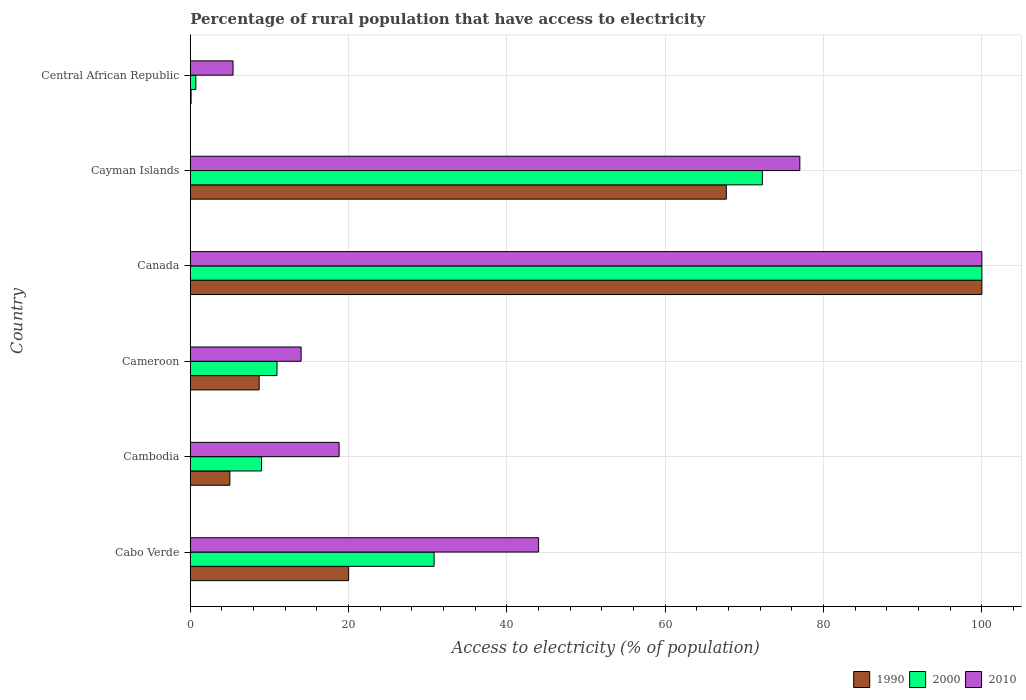How many groups of bars are there?
Your response must be concise. 6. Are the number of bars per tick equal to the number of legend labels?
Ensure brevity in your answer.  Yes. Are the number of bars on each tick of the Y-axis equal?
Provide a short and direct response. Yes. How many bars are there on the 2nd tick from the bottom?
Your answer should be compact. 3. What is the label of the 5th group of bars from the top?
Your answer should be compact. Cambodia. What is the percentage of rural population that have access to electricity in 2010 in Canada?
Your response must be concise. 100. In which country was the percentage of rural population that have access to electricity in 2000 minimum?
Provide a succinct answer. Central African Republic. What is the total percentage of rural population that have access to electricity in 2010 in the graph?
Provide a short and direct response. 259.2. What is the difference between the percentage of rural population that have access to electricity in 2000 in Cameroon and that in Cayman Islands?
Provide a succinct answer. -61.31. What is the difference between the percentage of rural population that have access to electricity in 2010 in Cabo Verde and the percentage of rural population that have access to electricity in 1990 in Cambodia?
Keep it short and to the point. 39. What is the average percentage of rural population that have access to electricity in 1990 per country?
Ensure brevity in your answer.  33.59. What is the difference between the percentage of rural population that have access to electricity in 1990 and percentage of rural population that have access to electricity in 2000 in Cabo Verde?
Provide a succinct answer. -10.8. In how many countries, is the percentage of rural population that have access to electricity in 2000 greater than 100 %?
Ensure brevity in your answer.  0. What is the ratio of the percentage of rural population that have access to electricity in 1990 in Cabo Verde to that in Canada?
Your response must be concise. 0.2. Is the difference between the percentage of rural population that have access to electricity in 1990 in Canada and Cayman Islands greater than the difference between the percentage of rural population that have access to electricity in 2000 in Canada and Cayman Islands?
Ensure brevity in your answer.  Yes. What is the difference between the highest and the second highest percentage of rural population that have access to electricity in 1990?
Your answer should be very brief. 32.29. What is the difference between the highest and the lowest percentage of rural population that have access to electricity in 1990?
Ensure brevity in your answer.  99.9. Is the sum of the percentage of rural population that have access to electricity in 2000 in Cabo Verde and Cambodia greater than the maximum percentage of rural population that have access to electricity in 2010 across all countries?
Your answer should be very brief. No. What does the 1st bar from the top in Cayman Islands represents?
Ensure brevity in your answer.  2010. What does the 1st bar from the bottom in Cabo Verde represents?
Make the answer very short. 1990. Is it the case that in every country, the sum of the percentage of rural population that have access to electricity in 2000 and percentage of rural population that have access to electricity in 1990 is greater than the percentage of rural population that have access to electricity in 2010?
Keep it short and to the point. No. How many countries are there in the graph?
Your answer should be compact. 6. Are the values on the major ticks of X-axis written in scientific E-notation?
Make the answer very short. No. Does the graph contain grids?
Provide a short and direct response. Yes. Where does the legend appear in the graph?
Offer a very short reply. Bottom right. How many legend labels are there?
Your answer should be compact. 3. How are the legend labels stacked?
Provide a short and direct response. Horizontal. What is the title of the graph?
Provide a short and direct response. Percentage of rural population that have access to electricity. What is the label or title of the X-axis?
Keep it short and to the point. Access to electricity (% of population). What is the Access to electricity (% of population) in 1990 in Cabo Verde?
Give a very brief answer. 20. What is the Access to electricity (% of population) in 2000 in Cabo Verde?
Keep it short and to the point. 30.8. What is the Access to electricity (% of population) of 2000 in Cambodia?
Offer a very short reply. 9. What is the Access to electricity (% of population) in 2000 in Cameroon?
Offer a very short reply. 10.95. What is the Access to electricity (% of population) in 1990 in Cayman Islands?
Your answer should be very brief. 67.71. What is the Access to electricity (% of population) in 2000 in Cayman Islands?
Offer a very short reply. 72.27. Across all countries, what is the maximum Access to electricity (% of population) of 1990?
Keep it short and to the point. 100. Across all countries, what is the minimum Access to electricity (% of population) in 1990?
Provide a short and direct response. 0.1. What is the total Access to electricity (% of population) of 1990 in the graph?
Give a very brief answer. 201.51. What is the total Access to electricity (% of population) of 2000 in the graph?
Keep it short and to the point. 223.72. What is the total Access to electricity (% of population) of 2010 in the graph?
Give a very brief answer. 259.2. What is the difference between the Access to electricity (% of population) of 2000 in Cabo Verde and that in Cambodia?
Provide a short and direct response. 21.8. What is the difference between the Access to electricity (% of population) in 2010 in Cabo Verde and that in Cambodia?
Offer a terse response. 25.2. What is the difference between the Access to electricity (% of population) in 1990 in Cabo Verde and that in Cameroon?
Give a very brief answer. 11.3. What is the difference between the Access to electricity (% of population) of 2000 in Cabo Verde and that in Cameroon?
Your answer should be very brief. 19.85. What is the difference between the Access to electricity (% of population) of 1990 in Cabo Verde and that in Canada?
Give a very brief answer. -80. What is the difference between the Access to electricity (% of population) in 2000 in Cabo Verde and that in Canada?
Your response must be concise. -69.2. What is the difference between the Access to electricity (% of population) in 2010 in Cabo Verde and that in Canada?
Provide a short and direct response. -56. What is the difference between the Access to electricity (% of population) in 1990 in Cabo Verde and that in Cayman Islands?
Give a very brief answer. -47.71. What is the difference between the Access to electricity (% of population) in 2000 in Cabo Verde and that in Cayman Islands?
Keep it short and to the point. -41.47. What is the difference between the Access to electricity (% of population) of 2010 in Cabo Verde and that in Cayman Islands?
Your answer should be very brief. -33. What is the difference between the Access to electricity (% of population) in 1990 in Cabo Verde and that in Central African Republic?
Your answer should be compact. 19.9. What is the difference between the Access to electricity (% of population) of 2000 in Cabo Verde and that in Central African Republic?
Offer a very short reply. 30.1. What is the difference between the Access to electricity (% of population) of 2010 in Cabo Verde and that in Central African Republic?
Provide a succinct answer. 38.6. What is the difference between the Access to electricity (% of population) of 2000 in Cambodia and that in Cameroon?
Offer a very short reply. -1.95. What is the difference between the Access to electricity (% of population) in 1990 in Cambodia and that in Canada?
Give a very brief answer. -95. What is the difference between the Access to electricity (% of population) in 2000 in Cambodia and that in Canada?
Your answer should be compact. -91. What is the difference between the Access to electricity (% of population) of 2010 in Cambodia and that in Canada?
Keep it short and to the point. -81.2. What is the difference between the Access to electricity (% of population) of 1990 in Cambodia and that in Cayman Islands?
Offer a terse response. -62.71. What is the difference between the Access to electricity (% of population) of 2000 in Cambodia and that in Cayman Islands?
Provide a short and direct response. -63.27. What is the difference between the Access to electricity (% of population) of 2010 in Cambodia and that in Cayman Islands?
Provide a short and direct response. -58.2. What is the difference between the Access to electricity (% of population) of 1990 in Cambodia and that in Central African Republic?
Offer a very short reply. 4.9. What is the difference between the Access to electricity (% of population) in 2000 in Cambodia and that in Central African Republic?
Provide a succinct answer. 8.3. What is the difference between the Access to electricity (% of population) of 2010 in Cambodia and that in Central African Republic?
Provide a short and direct response. 13.4. What is the difference between the Access to electricity (% of population) of 1990 in Cameroon and that in Canada?
Keep it short and to the point. -91.3. What is the difference between the Access to electricity (% of population) in 2000 in Cameroon and that in Canada?
Offer a very short reply. -89.05. What is the difference between the Access to electricity (% of population) of 2010 in Cameroon and that in Canada?
Ensure brevity in your answer.  -86. What is the difference between the Access to electricity (% of population) in 1990 in Cameroon and that in Cayman Islands?
Offer a very short reply. -59.01. What is the difference between the Access to electricity (% of population) of 2000 in Cameroon and that in Cayman Islands?
Provide a short and direct response. -61.31. What is the difference between the Access to electricity (% of population) of 2010 in Cameroon and that in Cayman Islands?
Provide a succinct answer. -63. What is the difference between the Access to electricity (% of population) in 1990 in Cameroon and that in Central African Republic?
Ensure brevity in your answer.  8.6. What is the difference between the Access to electricity (% of population) in 2000 in Cameroon and that in Central African Republic?
Offer a terse response. 10.25. What is the difference between the Access to electricity (% of population) of 1990 in Canada and that in Cayman Islands?
Your answer should be very brief. 32.29. What is the difference between the Access to electricity (% of population) of 2000 in Canada and that in Cayman Islands?
Your answer should be very brief. 27.73. What is the difference between the Access to electricity (% of population) in 2010 in Canada and that in Cayman Islands?
Your answer should be compact. 23. What is the difference between the Access to electricity (% of population) in 1990 in Canada and that in Central African Republic?
Keep it short and to the point. 99.9. What is the difference between the Access to electricity (% of population) in 2000 in Canada and that in Central African Republic?
Ensure brevity in your answer.  99.3. What is the difference between the Access to electricity (% of population) of 2010 in Canada and that in Central African Republic?
Your response must be concise. 94.6. What is the difference between the Access to electricity (% of population) of 1990 in Cayman Islands and that in Central African Republic?
Provide a short and direct response. 67.61. What is the difference between the Access to electricity (% of population) in 2000 in Cayman Islands and that in Central African Republic?
Provide a succinct answer. 71.56. What is the difference between the Access to electricity (% of population) of 2010 in Cayman Islands and that in Central African Republic?
Provide a short and direct response. 71.6. What is the difference between the Access to electricity (% of population) of 1990 in Cabo Verde and the Access to electricity (% of population) of 2000 in Cameroon?
Your answer should be compact. 9.05. What is the difference between the Access to electricity (% of population) in 1990 in Cabo Verde and the Access to electricity (% of population) in 2010 in Cameroon?
Ensure brevity in your answer.  6. What is the difference between the Access to electricity (% of population) in 2000 in Cabo Verde and the Access to electricity (% of population) in 2010 in Cameroon?
Make the answer very short. 16.8. What is the difference between the Access to electricity (% of population) in 1990 in Cabo Verde and the Access to electricity (% of population) in 2000 in Canada?
Provide a short and direct response. -80. What is the difference between the Access to electricity (% of population) in 1990 in Cabo Verde and the Access to electricity (% of population) in 2010 in Canada?
Offer a terse response. -80. What is the difference between the Access to electricity (% of population) in 2000 in Cabo Verde and the Access to electricity (% of population) in 2010 in Canada?
Your response must be concise. -69.2. What is the difference between the Access to electricity (% of population) in 1990 in Cabo Verde and the Access to electricity (% of population) in 2000 in Cayman Islands?
Provide a short and direct response. -52.27. What is the difference between the Access to electricity (% of population) in 1990 in Cabo Verde and the Access to electricity (% of population) in 2010 in Cayman Islands?
Provide a short and direct response. -57. What is the difference between the Access to electricity (% of population) of 2000 in Cabo Verde and the Access to electricity (% of population) of 2010 in Cayman Islands?
Your answer should be very brief. -46.2. What is the difference between the Access to electricity (% of population) of 1990 in Cabo Verde and the Access to electricity (% of population) of 2000 in Central African Republic?
Provide a succinct answer. 19.3. What is the difference between the Access to electricity (% of population) in 2000 in Cabo Verde and the Access to electricity (% of population) in 2010 in Central African Republic?
Offer a terse response. 25.4. What is the difference between the Access to electricity (% of population) in 1990 in Cambodia and the Access to electricity (% of population) in 2000 in Cameroon?
Ensure brevity in your answer.  -5.95. What is the difference between the Access to electricity (% of population) of 2000 in Cambodia and the Access to electricity (% of population) of 2010 in Cameroon?
Give a very brief answer. -5. What is the difference between the Access to electricity (% of population) of 1990 in Cambodia and the Access to electricity (% of population) of 2000 in Canada?
Provide a succinct answer. -95. What is the difference between the Access to electricity (% of population) of 1990 in Cambodia and the Access to electricity (% of population) of 2010 in Canada?
Your answer should be very brief. -95. What is the difference between the Access to electricity (% of population) in 2000 in Cambodia and the Access to electricity (% of population) in 2010 in Canada?
Ensure brevity in your answer.  -91. What is the difference between the Access to electricity (% of population) in 1990 in Cambodia and the Access to electricity (% of population) in 2000 in Cayman Islands?
Provide a succinct answer. -67.27. What is the difference between the Access to electricity (% of population) of 1990 in Cambodia and the Access to electricity (% of population) of 2010 in Cayman Islands?
Provide a succinct answer. -72. What is the difference between the Access to electricity (% of population) of 2000 in Cambodia and the Access to electricity (% of population) of 2010 in Cayman Islands?
Offer a very short reply. -68. What is the difference between the Access to electricity (% of population) of 1990 in Cameroon and the Access to electricity (% of population) of 2000 in Canada?
Your answer should be very brief. -91.3. What is the difference between the Access to electricity (% of population) of 1990 in Cameroon and the Access to electricity (% of population) of 2010 in Canada?
Provide a short and direct response. -91.3. What is the difference between the Access to electricity (% of population) of 2000 in Cameroon and the Access to electricity (% of population) of 2010 in Canada?
Your answer should be very brief. -89.05. What is the difference between the Access to electricity (% of population) in 1990 in Cameroon and the Access to electricity (% of population) in 2000 in Cayman Islands?
Your response must be concise. -63.56. What is the difference between the Access to electricity (% of population) of 1990 in Cameroon and the Access to electricity (% of population) of 2010 in Cayman Islands?
Make the answer very short. -68.3. What is the difference between the Access to electricity (% of population) of 2000 in Cameroon and the Access to electricity (% of population) of 2010 in Cayman Islands?
Give a very brief answer. -66.05. What is the difference between the Access to electricity (% of population) of 2000 in Cameroon and the Access to electricity (% of population) of 2010 in Central African Republic?
Make the answer very short. 5.55. What is the difference between the Access to electricity (% of population) in 1990 in Canada and the Access to electricity (% of population) in 2000 in Cayman Islands?
Ensure brevity in your answer.  27.73. What is the difference between the Access to electricity (% of population) in 1990 in Canada and the Access to electricity (% of population) in 2000 in Central African Republic?
Provide a succinct answer. 99.3. What is the difference between the Access to electricity (% of population) in 1990 in Canada and the Access to electricity (% of population) in 2010 in Central African Republic?
Give a very brief answer. 94.6. What is the difference between the Access to electricity (% of population) of 2000 in Canada and the Access to electricity (% of population) of 2010 in Central African Republic?
Provide a short and direct response. 94.6. What is the difference between the Access to electricity (% of population) of 1990 in Cayman Islands and the Access to electricity (% of population) of 2000 in Central African Republic?
Your answer should be compact. 67.01. What is the difference between the Access to electricity (% of population) of 1990 in Cayman Islands and the Access to electricity (% of population) of 2010 in Central African Republic?
Provide a succinct answer. 62.31. What is the difference between the Access to electricity (% of population) in 2000 in Cayman Islands and the Access to electricity (% of population) in 2010 in Central African Republic?
Ensure brevity in your answer.  66.86. What is the average Access to electricity (% of population) in 1990 per country?
Your answer should be very brief. 33.59. What is the average Access to electricity (% of population) of 2000 per country?
Ensure brevity in your answer.  37.29. What is the average Access to electricity (% of population) of 2010 per country?
Give a very brief answer. 43.2. What is the difference between the Access to electricity (% of population) in 1990 and Access to electricity (% of population) in 2000 in Cabo Verde?
Ensure brevity in your answer.  -10.8. What is the difference between the Access to electricity (% of population) in 1990 and Access to electricity (% of population) in 2000 in Cameroon?
Give a very brief answer. -2.25. What is the difference between the Access to electricity (% of population) in 2000 and Access to electricity (% of population) in 2010 in Cameroon?
Offer a very short reply. -3.05. What is the difference between the Access to electricity (% of population) in 1990 and Access to electricity (% of population) in 2000 in Canada?
Provide a short and direct response. 0. What is the difference between the Access to electricity (% of population) of 2000 and Access to electricity (% of population) of 2010 in Canada?
Offer a terse response. 0. What is the difference between the Access to electricity (% of population) of 1990 and Access to electricity (% of population) of 2000 in Cayman Islands?
Your response must be concise. -4.55. What is the difference between the Access to electricity (% of population) of 1990 and Access to electricity (% of population) of 2010 in Cayman Islands?
Offer a very short reply. -9.29. What is the difference between the Access to electricity (% of population) of 2000 and Access to electricity (% of population) of 2010 in Cayman Islands?
Offer a terse response. -4.74. What is the difference between the Access to electricity (% of population) in 1990 and Access to electricity (% of population) in 2010 in Central African Republic?
Ensure brevity in your answer.  -5.3. What is the difference between the Access to electricity (% of population) in 2000 and Access to electricity (% of population) in 2010 in Central African Republic?
Your response must be concise. -4.7. What is the ratio of the Access to electricity (% of population) in 1990 in Cabo Verde to that in Cambodia?
Keep it short and to the point. 4. What is the ratio of the Access to electricity (% of population) of 2000 in Cabo Verde to that in Cambodia?
Keep it short and to the point. 3.42. What is the ratio of the Access to electricity (% of population) in 2010 in Cabo Verde to that in Cambodia?
Your answer should be compact. 2.34. What is the ratio of the Access to electricity (% of population) in 1990 in Cabo Verde to that in Cameroon?
Your answer should be very brief. 2.3. What is the ratio of the Access to electricity (% of population) in 2000 in Cabo Verde to that in Cameroon?
Give a very brief answer. 2.81. What is the ratio of the Access to electricity (% of population) of 2010 in Cabo Verde to that in Cameroon?
Offer a terse response. 3.14. What is the ratio of the Access to electricity (% of population) in 1990 in Cabo Verde to that in Canada?
Your response must be concise. 0.2. What is the ratio of the Access to electricity (% of population) of 2000 in Cabo Verde to that in Canada?
Your response must be concise. 0.31. What is the ratio of the Access to electricity (% of population) of 2010 in Cabo Verde to that in Canada?
Provide a short and direct response. 0.44. What is the ratio of the Access to electricity (% of population) of 1990 in Cabo Verde to that in Cayman Islands?
Ensure brevity in your answer.  0.3. What is the ratio of the Access to electricity (% of population) of 2000 in Cabo Verde to that in Cayman Islands?
Make the answer very short. 0.43. What is the ratio of the Access to electricity (% of population) of 2010 in Cabo Verde to that in Central African Republic?
Your response must be concise. 8.15. What is the ratio of the Access to electricity (% of population) in 1990 in Cambodia to that in Cameroon?
Offer a very short reply. 0.57. What is the ratio of the Access to electricity (% of population) in 2000 in Cambodia to that in Cameroon?
Make the answer very short. 0.82. What is the ratio of the Access to electricity (% of population) of 2010 in Cambodia to that in Cameroon?
Offer a terse response. 1.34. What is the ratio of the Access to electricity (% of population) of 2000 in Cambodia to that in Canada?
Provide a succinct answer. 0.09. What is the ratio of the Access to electricity (% of population) in 2010 in Cambodia to that in Canada?
Keep it short and to the point. 0.19. What is the ratio of the Access to electricity (% of population) in 1990 in Cambodia to that in Cayman Islands?
Your answer should be compact. 0.07. What is the ratio of the Access to electricity (% of population) in 2000 in Cambodia to that in Cayman Islands?
Offer a very short reply. 0.12. What is the ratio of the Access to electricity (% of population) of 2010 in Cambodia to that in Cayman Islands?
Offer a very short reply. 0.24. What is the ratio of the Access to electricity (% of population) of 2000 in Cambodia to that in Central African Republic?
Provide a short and direct response. 12.86. What is the ratio of the Access to electricity (% of population) in 2010 in Cambodia to that in Central African Republic?
Ensure brevity in your answer.  3.48. What is the ratio of the Access to electricity (% of population) in 1990 in Cameroon to that in Canada?
Keep it short and to the point. 0.09. What is the ratio of the Access to electricity (% of population) of 2000 in Cameroon to that in Canada?
Your answer should be very brief. 0.11. What is the ratio of the Access to electricity (% of population) in 2010 in Cameroon to that in Canada?
Offer a terse response. 0.14. What is the ratio of the Access to electricity (% of population) in 1990 in Cameroon to that in Cayman Islands?
Give a very brief answer. 0.13. What is the ratio of the Access to electricity (% of population) of 2000 in Cameroon to that in Cayman Islands?
Your answer should be compact. 0.15. What is the ratio of the Access to electricity (% of population) in 2010 in Cameroon to that in Cayman Islands?
Offer a very short reply. 0.18. What is the ratio of the Access to electricity (% of population) in 2000 in Cameroon to that in Central African Republic?
Provide a short and direct response. 15.64. What is the ratio of the Access to electricity (% of population) in 2010 in Cameroon to that in Central African Republic?
Keep it short and to the point. 2.59. What is the ratio of the Access to electricity (% of population) in 1990 in Canada to that in Cayman Islands?
Offer a very short reply. 1.48. What is the ratio of the Access to electricity (% of population) in 2000 in Canada to that in Cayman Islands?
Ensure brevity in your answer.  1.38. What is the ratio of the Access to electricity (% of population) of 2010 in Canada to that in Cayman Islands?
Keep it short and to the point. 1.3. What is the ratio of the Access to electricity (% of population) of 1990 in Canada to that in Central African Republic?
Provide a succinct answer. 1000. What is the ratio of the Access to electricity (% of population) in 2000 in Canada to that in Central African Republic?
Your answer should be very brief. 142.86. What is the ratio of the Access to electricity (% of population) of 2010 in Canada to that in Central African Republic?
Provide a short and direct response. 18.52. What is the ratio of the Access to electricity (% of population) in 1990 in Cayman Islands to that in Central African Republic?
Offer a terse response. 677.11. What is the ratio of the Access to electricity (% of population) in 2000 in Cayman Islands to that in Central African Republic?
Provide a short and direct response. 103.24. What is the ratio of the Access to electricity (% of population) in 2010 in Cayman Islands to that in Central African Republic?
Keep it short and to the point. 14.26. What is the difference between the highest and the second highest Access to electricity (% of population) in 1990?
Keep it short and to the point. 32.29. What is the difference between the highest and the second highest Access to electricity (% of population) in 2000?
Offer a very short reply. 27.73. What is the difference between the highest and the lowest Access to electricity (% of population) in 1990?
Your answer should be very brief. 99.9. What is the difference between the highest and the lowest Access to electricity (% of population) in 2000?
Give a very brief answer. 99.3. What is the difference between the highest and the lowest Access to electricity (% of population) in 2010?
Ensure brevity in your answer.  94.6. 